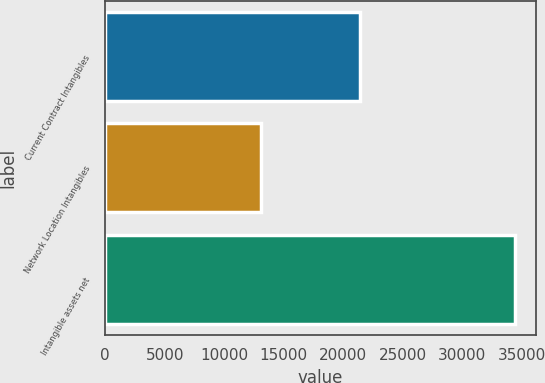<chart> <loc_0><loc_0><loc_500><loc_500><bar_chart><fcel>Current Contract Intangibles<fcel>Network Location Intangibles<fcel>Intangible assets net<nl><fcel>21405<fcel>13052<fcel>34457<nl></chart> 